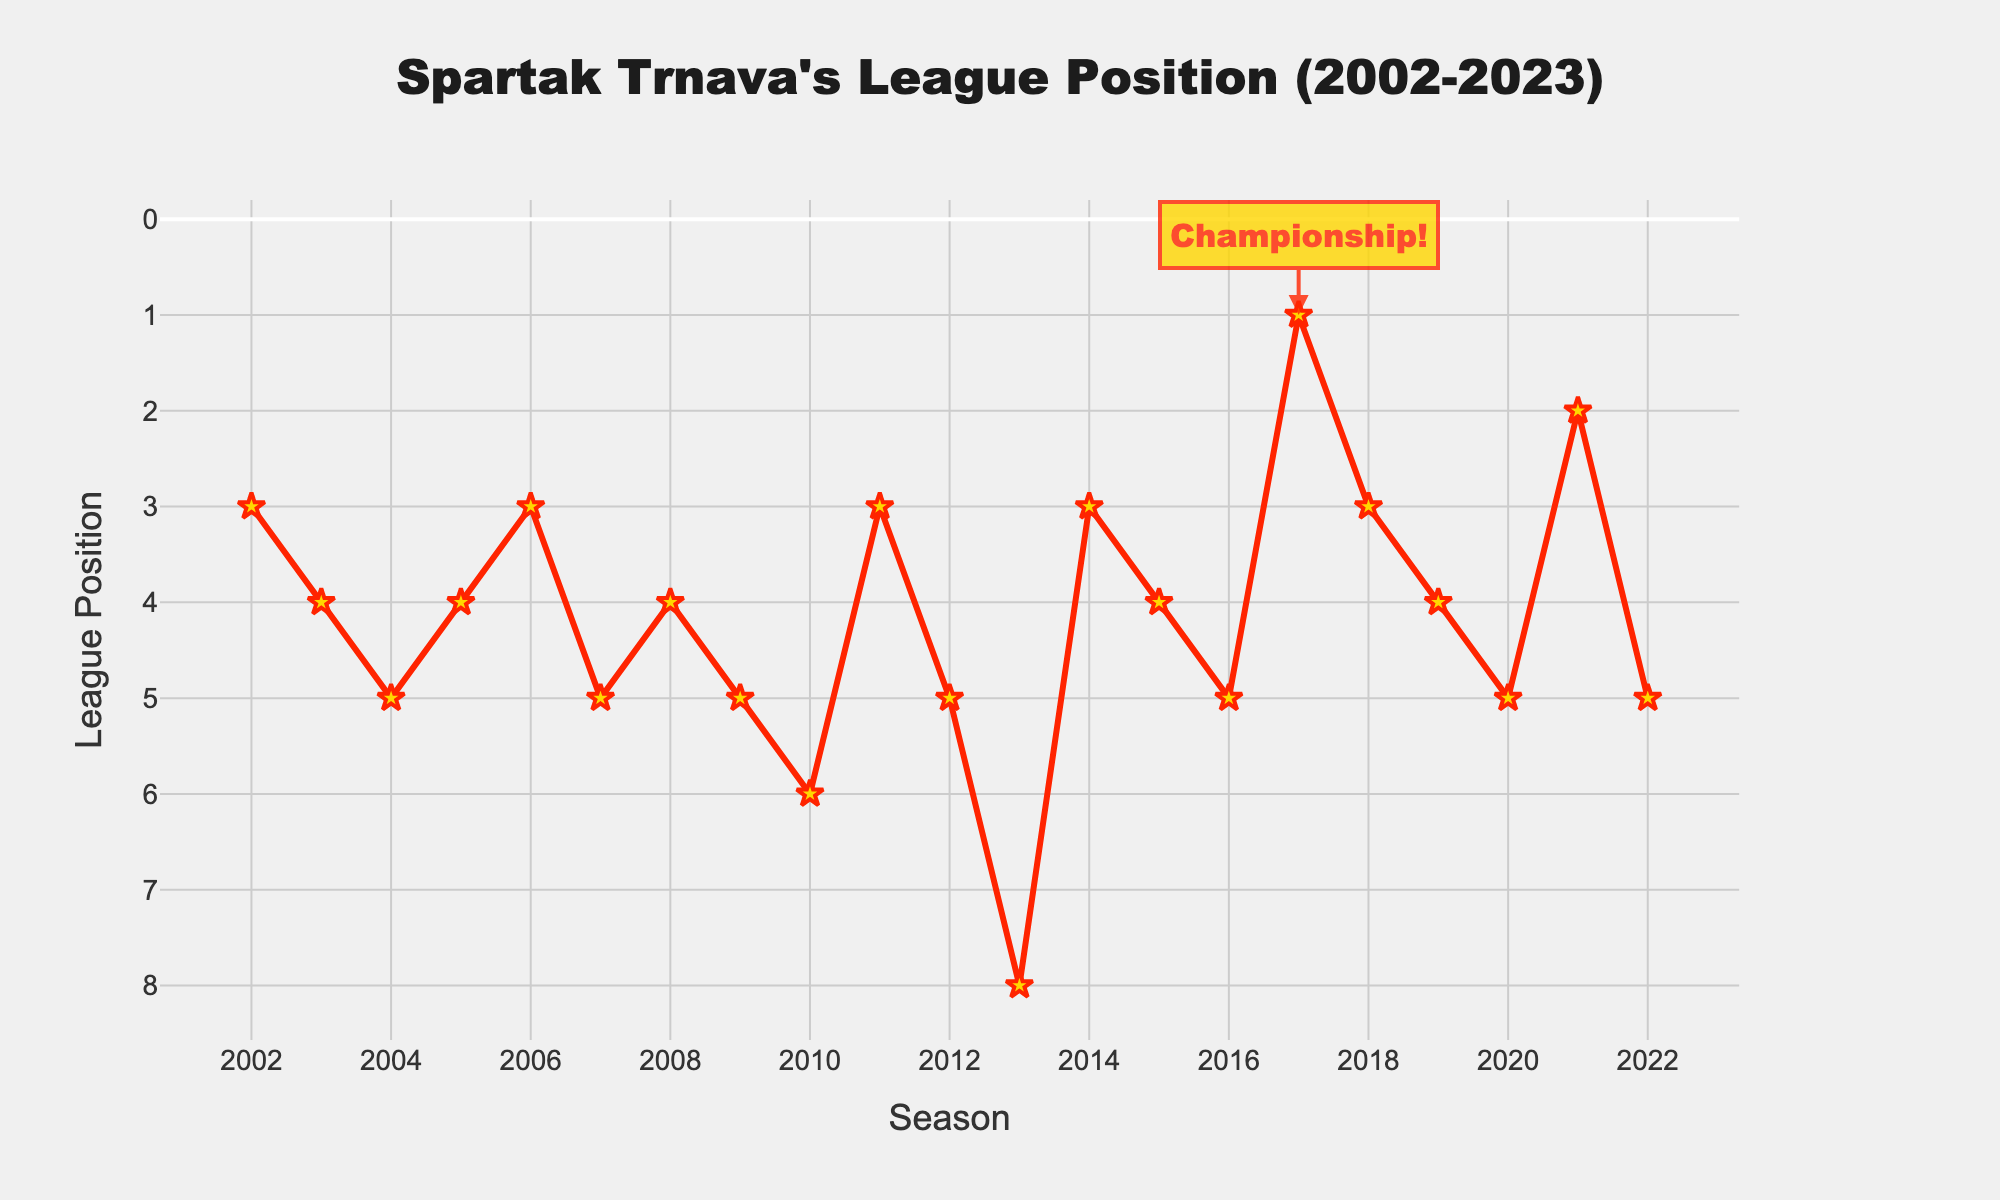What's the best league position Spartak Trnava achieved from 2002 to 2023? The best position Spartak Trnava achieved is indicated by the lowest point on the y-axis since lower values represent better league positions. The lowest point on the line chart is 1st position in the 2017/18 season.
Answer: 1st In which season did Spartak Trnava finish in 1st place? The chart shows a special annotation at the point where Spartak Trnava achieved 1st place, which is visually marked with "Championship!" at the x-axis value corresponding to 2017/18.
Answer: 2017/18 How often did Spartak Trnava finish in 3rd place from 2002 to 2023? To determine how often Spartak Trnava finished in 3rd place, count the number of points on the line chart at the y-axis value of 3. These seasons are 2002/03, 2006/07, 2011/12, 2014/15, and 2018/19, resulting in 5 occurrences.
Answer: 5 Which season had the lowest league position, and what was that position? The lowest league position is indicated by the highest point on the y-axis. The highest point is at the 8th position during the 2013/14 season.
Answer: 2013/14, 8th What is the average league position of Spartak Trnava in the past 5 seasons? To find the average league position, first identify the positions from the past 5 seasons: 3 (2018/19), 4 (2019/20), 5 (2020/21), 2 (2021/22), and 5 (2022/23). Sum these positions (3 + 4 + 5 + 2 + 5 = 19) and divide by 5, resulting in an average position of 3.8.
Answer: 3.8 Did Spartak Trnava improve or decline in league position from 2020/21 to 2021/22? Comparing the positions from the two seasons, Spartak Trnava's position improved from 5th in 2020/21 to 2nd in 2021/22.
Answer: Improved Which season had the largest jump in league position from the previous season, and what was that jump? To find the largest jump, compare the differences in league positions between consecutive seasons. The largest jump occurred from 2016/17 (5th) to 2017/18 (1st), representing a jump of 4 positions.
Answer: 2017/18, 4 positions What is the median league position of Spartak Trnava over the 20 seasons? To find the median position, list all the positions in ascending order: 1, 2, 3, 3, 3, 3, 3, 4, 4, 4, 4, 4, 5, 5, 5, 5, 5, 5, 6, 8. The median of the ordered list (20 values) is the average of the 10th and 11th values, both of which are 4. Thus, the median is 4.
Answer: 4 